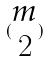Convert formula to latex. <formula><loc_0><loc_0><loc_500><loc_500>( \begin{matrix} m \\ 2 \end{matrix} )</formula> 